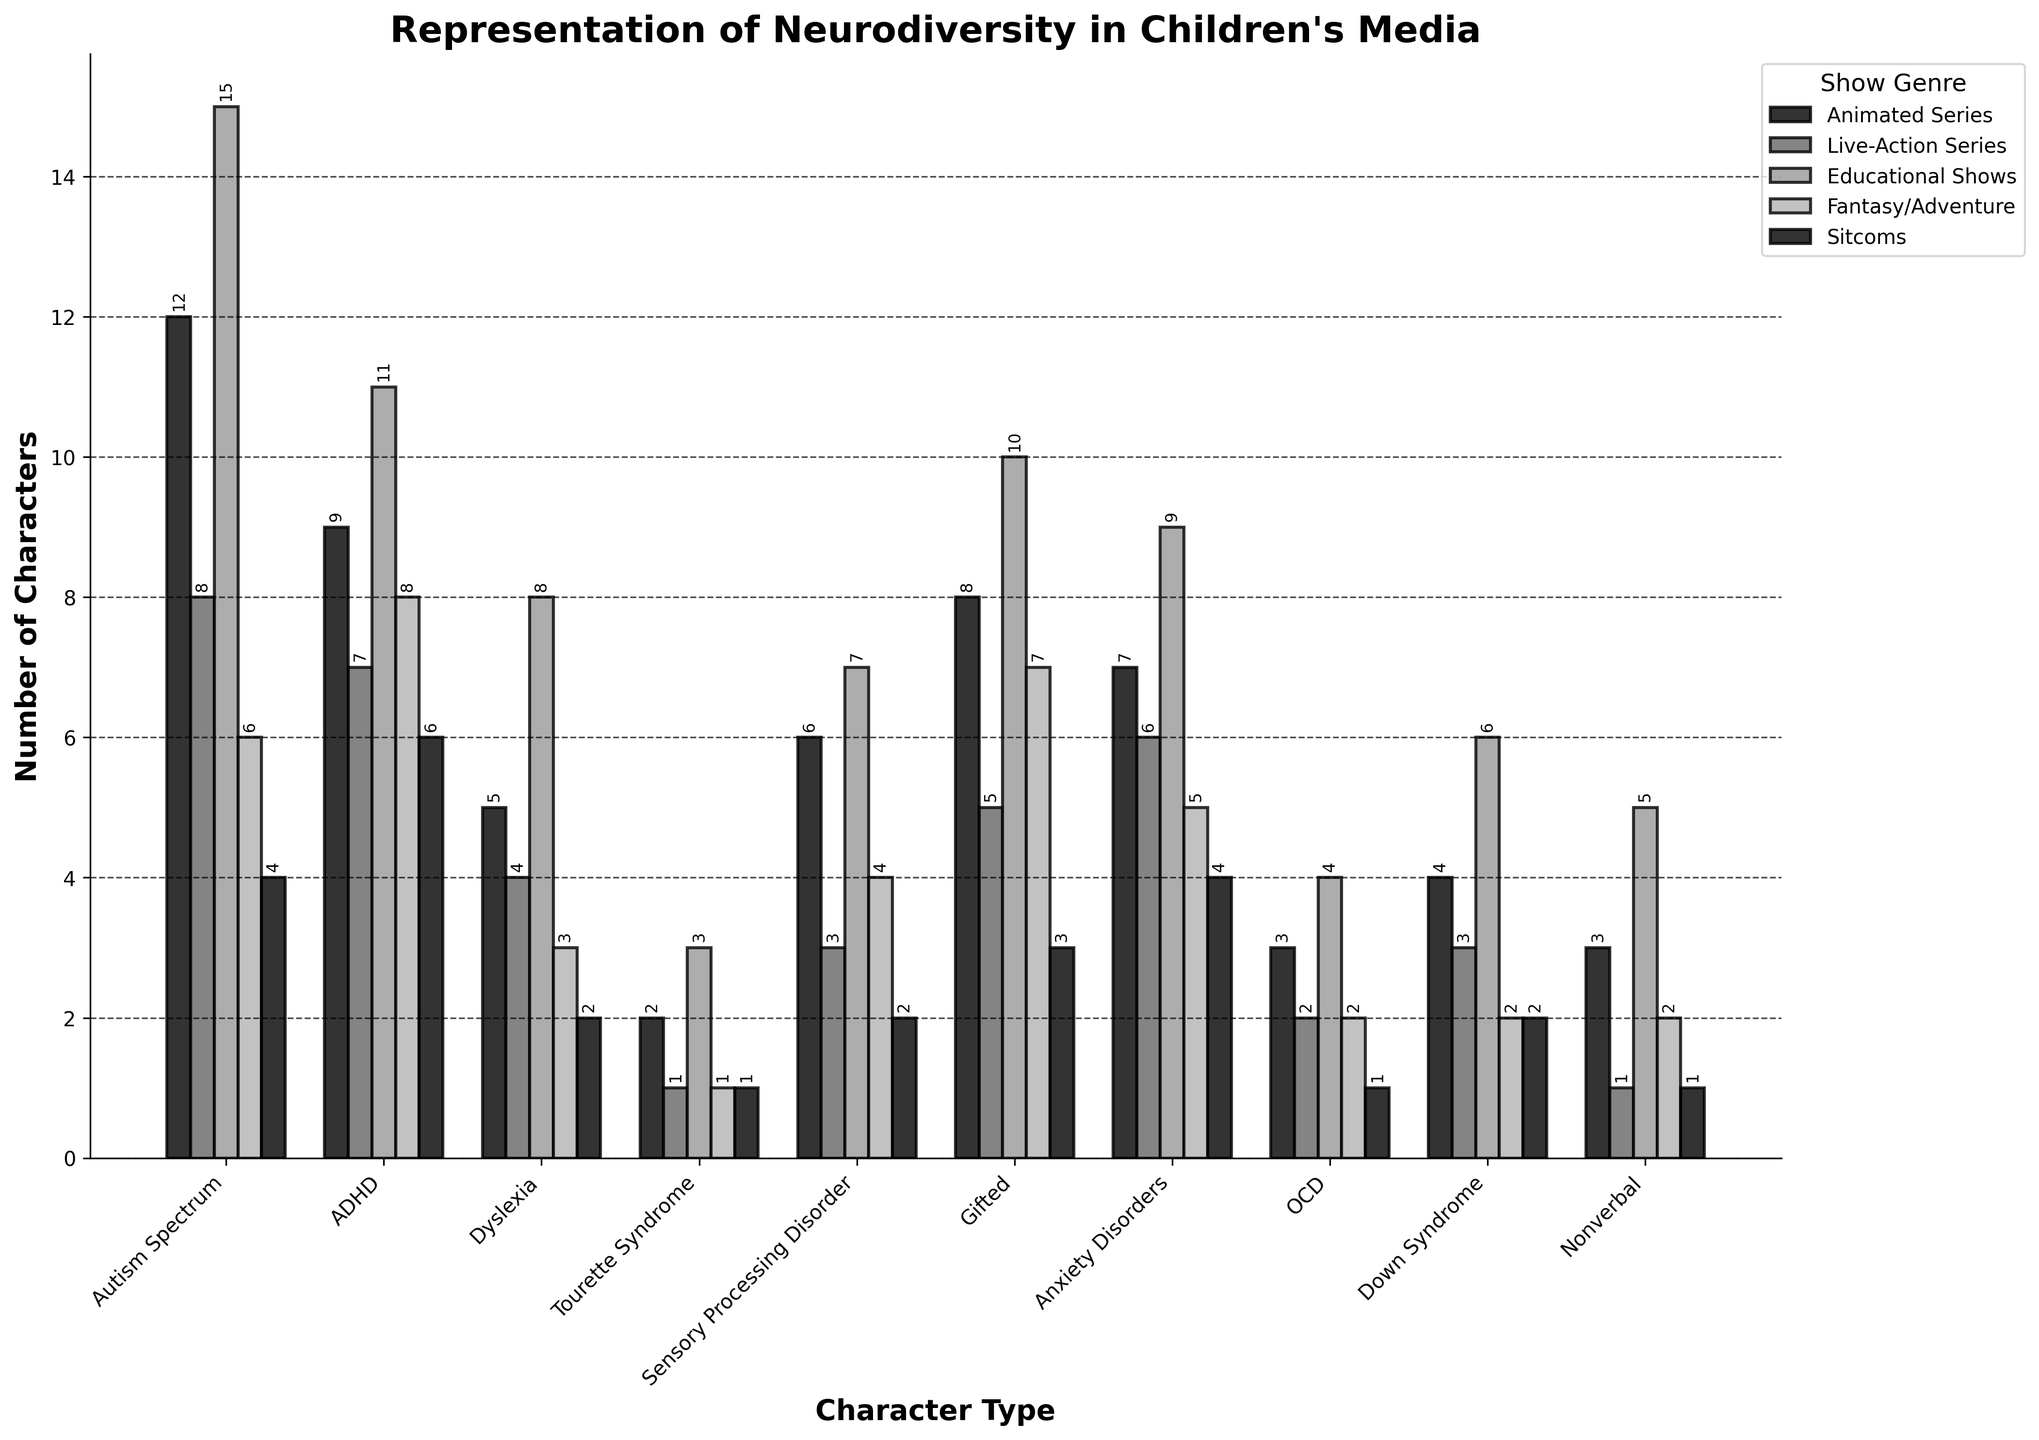What's the most represented character type in animated series? The bar representing "Autism Spectrum" for animated series is the tallest among the character types. This means there are 12 characters with Autism Spectrum in animated series, which is higher than any other character type in this genre.
Answer: Autism Spectrum Which character type has the least representation in sitcoms? The bar for "Tourette Syndrome" and "Nonverbal" are the shortest in the sitcoms category. Both have the same height, indicating 1 character each. Since both have the same representation, either answer is correct.
Answer: Tourette Syndrome, Nonverbal What's the total number of characters with Dyslexia across all show genres? Sum the values for Dyslexia across all genres: 5 (Animated Series) + 4 (Live-Action Series) + 8 (Educational Shows) + 3 (Fantasy/Adventure) + 2 (Sitcoms). The total is 5 + 4 + 8 + 3 + 2 = 22.
Answer: 22 Are there more characters with ADHD or OCD in educational shows? Compare the heights of the bars in the Educational Shows genre for ADHD and OCD. ADHD has a taller bar with 11 characters, while OCD has a shorter bar with 4 characters.
Answer: ADHD Which show genre has the highest representation of characters with Down Syndrome? Identify the tallest bar for Down Syndrome across the genres. In this case, Educational Shows have the highest bar representing 6 characters with Down Syndrome.
Answer: Educational Shows Among the character types represented in educational shows and fantasy/adventure genres, which type appears twice as much in educational shows than in fantasy/adventure? Compare the bars between educational shows and fantasy/adventure for each character type. "Gifted" appears 10 times in educational shows and 5 times in fantasy/adventure, which is twice as much.
Answer: Gifted What's the difference in the number of characters with Sensory Processing Disorder in live-action series and animated series? Subtract the number of characters in live-action series (3) from the number in animated series (6): 6 - 3 = 3.
Answer: 3 How many character types have at least 1 character represented in live-action series? Count the number of bars with a height greater than 0 in the live-action series. There are 8 character types with at least 1 character in live-action series (Autism Spectrum, ADHD, Dyslexia, Sensory Processing Disorder, Gifted, Anxiety Disorders, OCD, Down Syndrome).
Answer: 8 What is the average number of characters with Autism Spectrum, ADHD, and Gifted in sitcoms? Sum the values for these three character types in sitcoms: 4 (Autism Spectrum) + 6 (ADHD) + 3 (Gifted) = 13. Then divide the total by 3 (number of types): 13 / 3 ≈ 4.33.
Answer: 4.33 